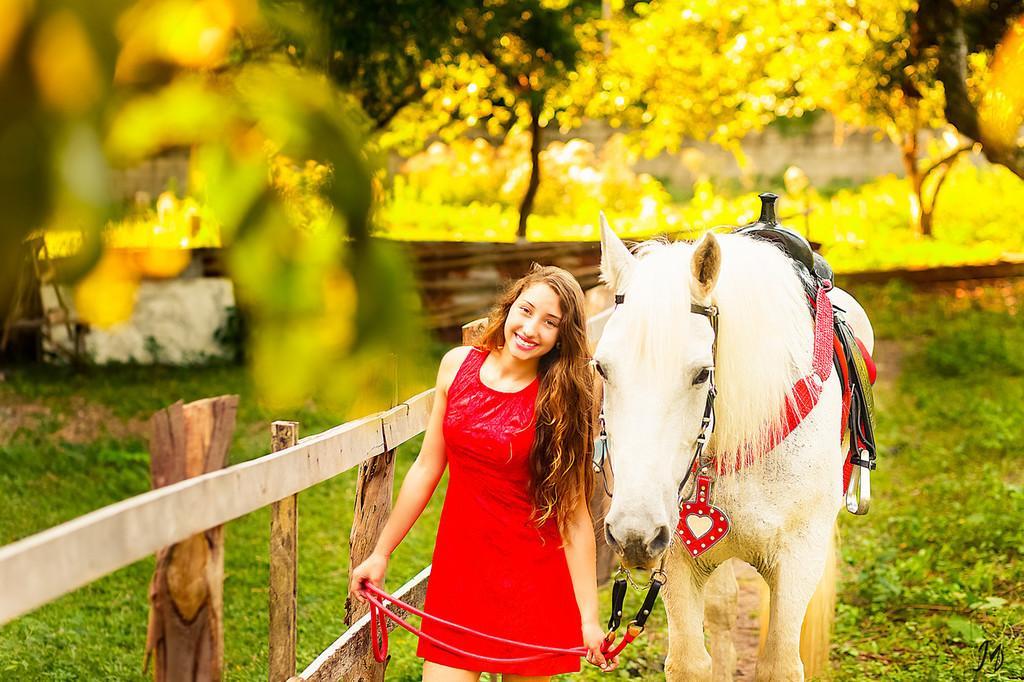How would you summarize this image in a sentence or two? In this image I see a woman who is wearing a red dress and she is standing and smiling. I can also see that she is holding a rope which is tied to this horse and they're on the grass. In the background I see the trees. 